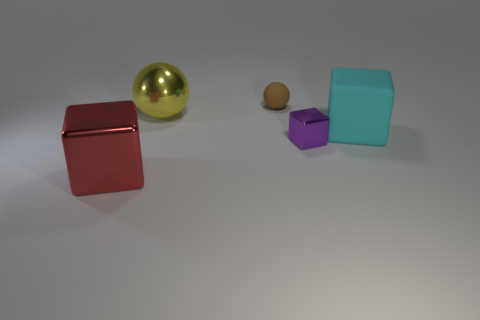Subtract all tiny purple metal cubes. How many cubes are left? 2 Add 4 rubber cubes. How many objects exist? 9 Subtract all spheres. How many objects are left? 3 Add 3 red blocks. How many red blocks exist? 4 Subtract 0 blue cylinders. How many objects are left? 5 Subtract all yellow matte cubes. Subtract all big cyan blocks. How many objects are left? 4 Add 1 yellow metallic balls. How many yellow metallic balls are left? 2 